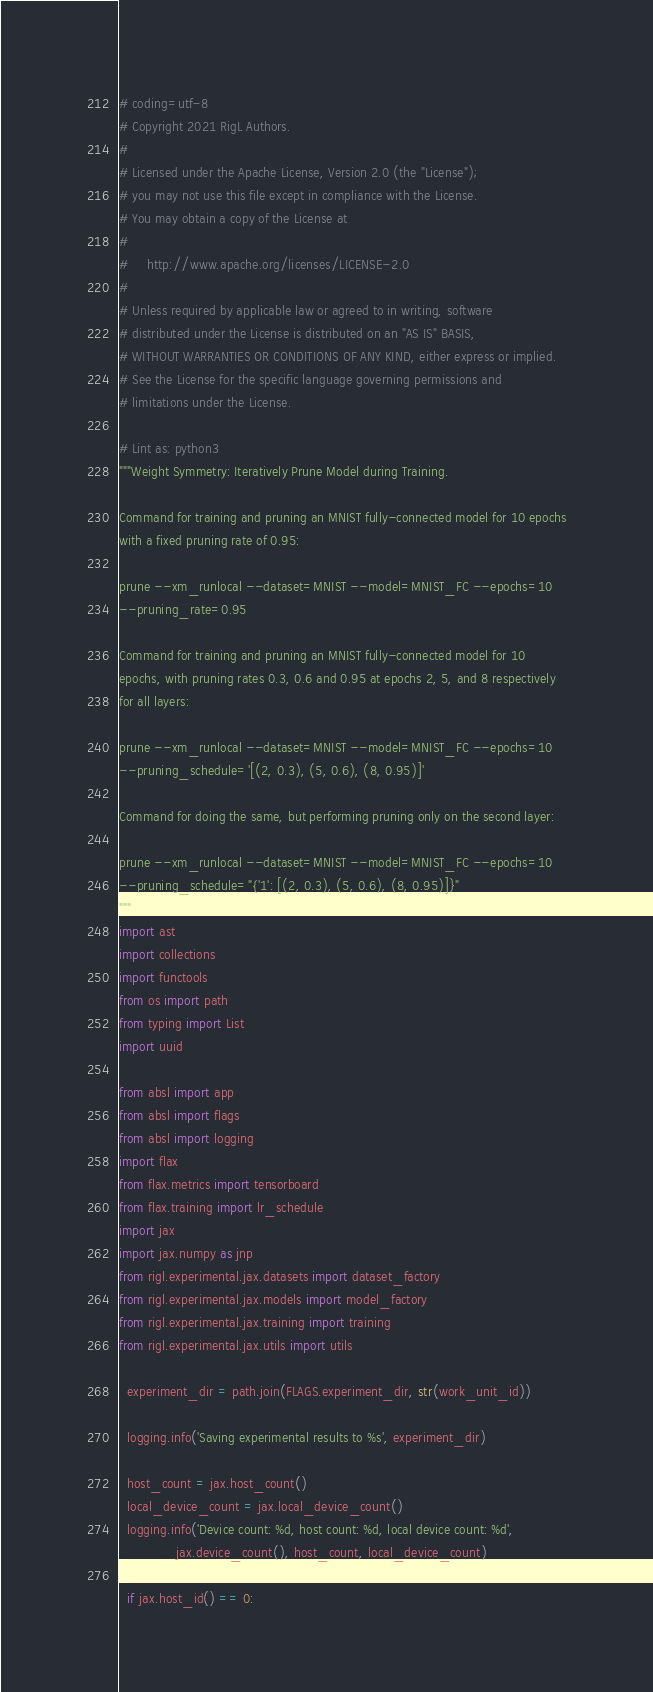<code> <loc_0><loc_0><loc_500><loc_500><_Python_># coding=utf-8
# Copyright 2021 RigL Authors.
#
# Licensed under the Apache License, Version 2.0 (the "License");
# you may not use this file except in compliance with the License.
# You may obtain a copy of the License at
#
#     http://www.apache.org/licenses/LICENSE-2.0
#
# Unless required by applicable law or agreed to in writing, software
# distributed under the License is distributed on an "AS IS" BASIS,
# WITHOUT WARRANTIES OR CONDITIONS OF ANY KIND, either express or implied.
# See the License for the specific language governing permissions and
# limitations under the License.

# Lint as: python3
"""Weight Symmetry: Iteratively Prune Model during Training.

Command for training and pruning an MNIST fully-connected model for 10 epochs
with a fixed pruning rate of 0.95:

prune --xm_runlocal --dataset=MNIST --model=MNIST_FC --epochs=10
--pruning_rate=0.95

Command for training and pruning an MNIST fully-connected model for 10
epochs, with pruning rates 0.3, 0.6 and 0.95 at epochs 2, 5, and 8 respectively
for all layers:

prune --xm_runlocal --dataset=MNIST --model=MNIST_FC --epochs=10
--pruning_schedule='[(2, 0.3), (5, 0.6), (8, 0.95)]'

Command for doing the same, but performing pruning only on the second layer:

prune --xm_runlocal --dataset=MNIST --model=MNIST_FC --epochs=10
--pruning_schedule="{'1': [(2, 0.3), (5, 0.6), (8, 0.95)]}"
"""
import ast
import collections
import functools
from os import path
from typing import List
import uuid

from absl import app
from absl import flags
from absl import logging
import flax
from flax.metrics import tensorboard
from flax.training import lr_schedule
import jax
import jax.numpy as jnp
from rigl.experimental.jax.datasets import dataset_factory
from rigl.experimental.jax.models import model_factory
from rigl.experimental.jax.training import training
from rigl.experimental.jax.utils import utils

  experiment_dir = path.join(FLAGS.experiment_dir, str(work_unit_id))

  logging.info('Saving experimental results to %s', experiment_dir)

  host_count = jax.host_count()
  local_device_count = jax.local_device_count()
  logging.info('Device count: %d, host count: %d, local device count: %d',
               jax.device_count(), host_count, local_device_count)

  if jax.host_id() == 0:</code> 